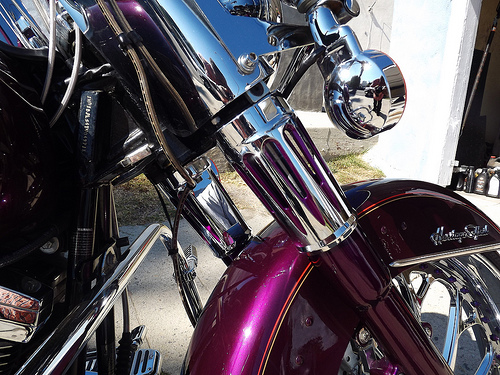<image>
Is there a wheel under the wall? No. The wheel is not positioned under the wall. The vertical relationship between these objects is different. 